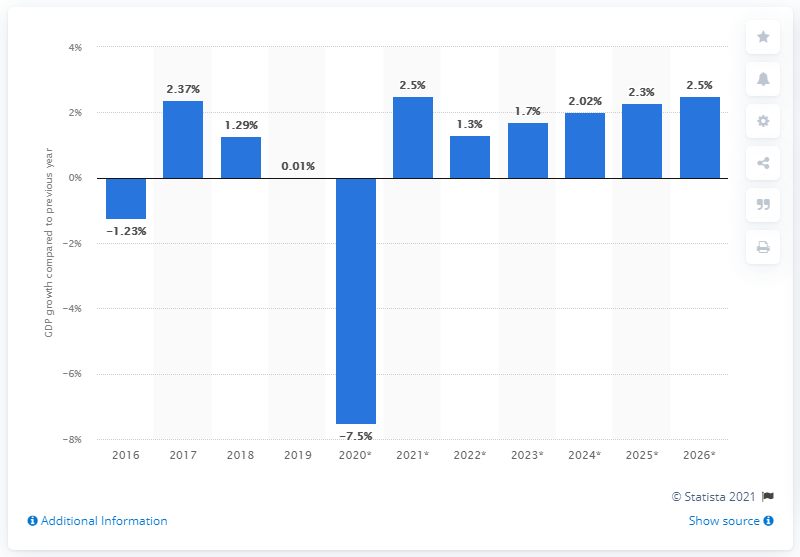Outline some significant characteristics in this image. Ecuador's real GDP grew by 0.01% in 2019. 